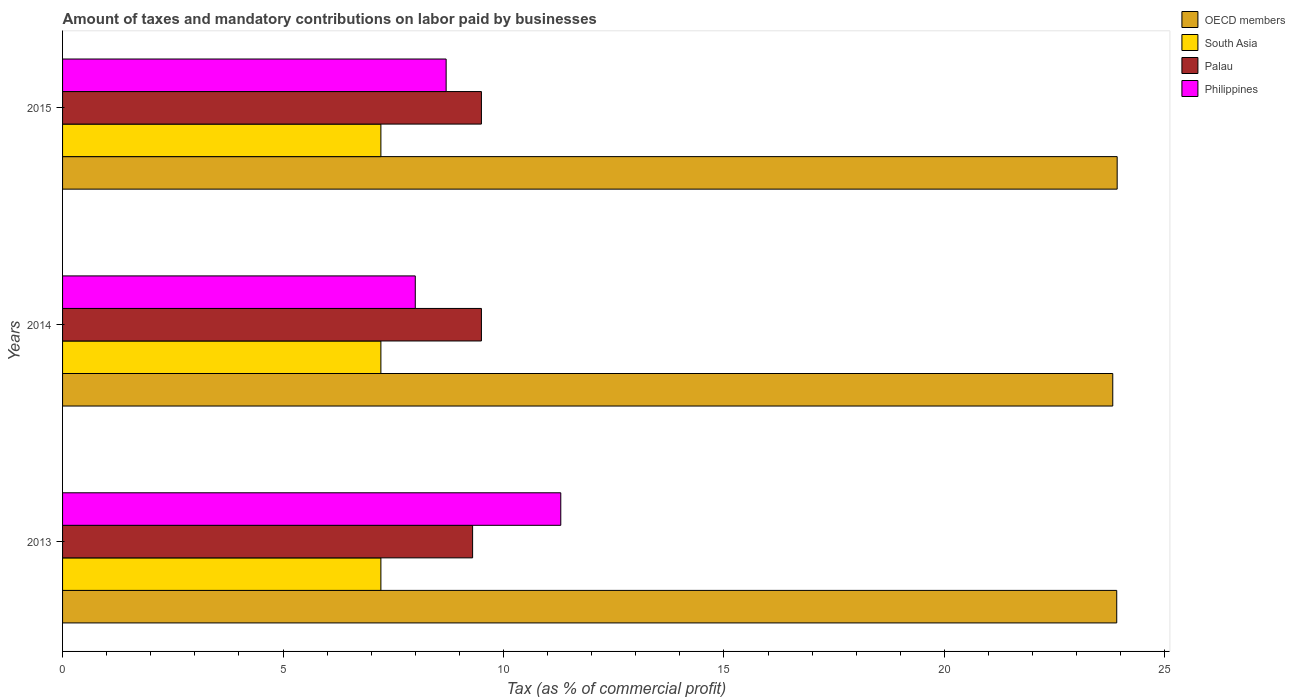How many bars are there on the 1st tick from the top?
Give a very brief answer. 4. What is the label of the 3rd group of bars from the top?
Ensure brevity in your answer.  2013. What is the percentage of taxes paid by businesses in South Asia in 2014?
Offer a very short reply. 7.22. Across all years, what is the maximum percentage of taxes paid by businesses in South Asia?
Provide a succinct answer. 7.22. Across all years, what is the minimum percentage of taxes paid by businesses in Palau?
Your answer should be compact. 9.3. In which year was the percentage of taxes paid by businesses in Palau maximum?
Make the answer very short. 2014. What is the total percentage of taxes paid by businesses in OECD members in the graph?
Keep it short and to the point. 71.65. What is the difference between the percentage of taxes paid by businesses in OECD members in 2013 and that in 2015?
Your response must be concise. -0.01. What is the difference between the percentage of taxes paid by businesses in Philippines in 2014 and the percentage of taxes paid by businesses in Palau in 2015?
Provide a short and direct response. -1.5. What is the average percentage of taxes paid by businesses in South Asia per year?
Make the answer very short. 7.22. In the year 2015, what is the difference between the percentage of taxes paid by businesses in Palau and percentage of taxes paid by businesses in OECD members?
Offer a very short reply. -14.42. What is the ratio of the percentage of taxes paid by businesses in Philippines in 2013 to that in 2014?
Your answer should be very brief. 1.41. What is the difference between the highest and the second highest percentage of taxes paid by businesses in Philippines?
Keep it short and to the point. 2.6. What is the difference between the highest and the lowest percentage of taxes paid by businesses in Philippines?
Give a very brief answer. 3.3. Is the sum of the percentage of taxes paid by businesses in Palau in 2013 and 2015 greater than the maximum percentage of taxes paid by businesses in South Asia across all years?
Provide a short and direct response. Yes. What does the 3rd bar from the top in 2013 represents?
Provide a short and direct response. South Asia. What does the 3rd bar from the bottom in 2013 represents?
Provide a short and direct response. Palau. Is it the case that in every year, the sum of the percentage of taxes paid by businesses in OECD members and percentage of taxes paid by businesses in Palau is greater than the percentage of taxes paid by businesses in Philippines?
Keep it short and to the point. Yes. Are all the bars in the graph horizontal?
Your response must be concise. Yes. Are the values on the major ticks of X-axis written in scientific E-notation?
Provide a succinct answer. No. Does the graph contain any zero values?
Your answer should be very brief. No. Does the graph contain grids?
Offer a terse response. No. How are the legend labels stacked?
Make the answer very short. Vertical. What is the title of the graph?
Provide a succinct answer. Amount of taxes and mandatory contributions on labor paid by businesses. Does "Finland" appear as one of the legend labels in the graph?
Make the answer very short. No. What is the label or title of the X-axis?
Ensure brevity in your answer.  Tax (as % of commercial profit). What is the Tax (as % of commercial profit) of OECD members in 2013?
Your answer should be very brief. 23.91. What is the Tax (as % of commercial profit) in South Asia in 2013?
Provide a succinct answer. 7.22. What is the Tax (as % of commercial profit) in Palau in 2013?
Your answer should be very brief. 9.3. What is the Tax (as % of commercial profit) of OECD members in 2014?
Give a very brief answer. 23.82. What is the Tax (as % of commercial profit) of South Asia in 2014?
Your answer should be very brief. 7.22. What is the Tax (as % of commercial profit) of Palau in 2014?
Your response must be concise. 9.5. What is the Tax (as % of commercial profit) of Philippines in 2014?
Offer a terse response. 8. What is the Tax (as % of commercial profit) of OECD members in 2015?
Your answer should be very brief. 23.92. What is the Tax (as % of commercial profit) in South Asia in 2015?
Provide a short and direct response. 7.22. What is the Tax (as % of commercial profit) of Palau in 2015?
Keep it short and to the point. 9.5. What is the Tax (as % of commercial profit) in Philippines in 2015?
Your answer should be compact. 8.7. Across all years, what is the maximum Tax (as % of commercial profit) in OECD members?
Your answer should be compact. 23.92. Across all years, what is the maximum Tax (as % of commercial profit) in South Asia?
Ensure brevity in your answer.  7.22. Across all years, what is the maximum Tax (as % of commercial profit) of Palau?
Provide a succinct answer. 9.5. Across all years, what is the minimum Tax (as % of commercial profit) in OECD members?
Ensure brevity in your answer.  23.82. Across all years, what is the minimum Tax (as % of commercial profit) in South Asia?
Make the answer very short. 7.22. Across all years, what is the minimum Tax (as % of commercial profit) in Palau?
Provide a succinct answer. 9.3. What is the total Tax (as % of commercial profit) in OECD members in the graph?
Offer a very short reply. 71.65. What is the total Tax (as % of commercial profit) of South Asia in the graph?
Your answer should be compact. 21.66. What is the total Tax (as % of commercial profit) in Palau in the graph?
Make the answer very short. 28.3. What is the difference between the Tax (as % of commercial profit) in OECD members in 2013 and that in 2014?
Ensure brevity in your answer.  0.09. What is the difference between the Tax (as % of commercial profit) of Palau in 2013 and that in 2014?
Provide a succinct answer. -0.2. What is the difference between the Tax (as % of commercial profit) of OECD members in 2013 and that in 2015?
Keep it short and to the point. -0.01. What is the difference between the Tax (as % of commercial profit) in Philippines in 2013 and that in 2015?
Keep it short and to the point. 2.6. What is the difference between the Tax (as % of commercial profit) in South Asia in 2014 and that in 2015?
Your response must be concise. 0. What is the difference between the Tax (as % of commercial profit) of Palau in 2014 and that in 2015?
Keep it short and to the point. 0. What is the difference between the Tax (as % of commercial profit) of OECD members in 2013 and the Tax (as % of commercial profit) of South Asia in 2014?
Give a very brief answer. 16.69. What is the difference between the Tax (as % of commercial profit) in OECD members in 2013 and the Tax (as % of commercial profit) in Palau in 2014?
Your response must be concise. 14.41. What is the difference between the Tax (as % of commercial profit) of OECD members in 2013 and the Tax (as % of commercial profit) of Philippines in 2014?
Your answer should be very brief. 15.91. What is the difference between the Tax (as % of commercial profit) in South Asia in 2013 and the Tax (as % of commercial profit) in Palau in 2014?
Keep it short and to the point. -2.28. What is the difference between the Tax (as % of commercial profit) of South Asia in 2013 and the Tax (as % of commercial profit) of Philippines in 2014?
Ensure brevity in your answer.  -0.78. What is the difference between the Tax (as % of commercial profit) of OECD members in 2013 and the Tax (as % of commercial profit) of South Asia in 2015?
Offer a terse response. 16.69. What is the difference between the Tax (as % of commercial profit) of OECD members in 2013 and the Tax (as % of commercial profit) of Palau in 2015?
Make the answer very short. 14.41. What is the difference between the Tax (as % of commercial profit) in OECD members in 2013 and the Tax (as % of commercial profit) in Philippines in 2015?
Your answer should be very brief. 15.21. What is the difference between the Tax (as % of commercial profit) in South Asia in 2013 and the Tax (as % of commercial profit) in Palau in 2015?
Give a very brief answer. -2.28. What is the difference between the Tax (as % of commercial profit) in South Asia in 2013 and the Tax (as % of commercial profit) in Philippines in 2015?
Your answer should be very brief. -1.48. What is the difference between the Tax (as % of commercial profit) of Palau in 2013 and the Tax (as % of commercial profit) of Philippines in 2015?
Keep it short and to the point. 0.6. What is the difference between the Tax (as % of commercial profit) in OECD members in 2014 and the Tax (as % of commercial profit) in South Asia in 2015?
Give a very brief answer. 16.6. What is the difference between the Tax (as % of commercial profit) of OECD members in 2014 and the Tax (as % of commercial profit) of Palau in 2015?
Provide a short and direct response. 14.32. What is the difference between the Tax (as % of commercial profit) in OECD members in 2014 and the Tax (as % of commercial profit) in Philippines in 2015?
Provide a succinct answer. 15.12. What is the difference between the Tax (as % of commercial profit) of South Asia in 2014 and the Tax (as % of commercial profit) of Palau in 2015?
Give a very brief answer. -2.28. What is the difference between the Tax (as % of commercial profit) in South Asia in 2014 and the Tax (as % of commercial profit) in Philippines in 2015?
Provide a succinct answer. -1.48. What is the difference between the Tax (as % of commercial profit) of Palau in 2014 and the Tax (as % of commercial profit) of Philippines in 2015?
Your response must be concise. 0.8. What is the average Tax (as % of commercial profit) in OECD members per year?
Provide a succinct answer. 23.88. What is the average Tax (as % of commercial profit) of South Asia per year?
Ensure brevity in your answer.  7.22. What is the average Tax (as % of commercial profit) in Palau per year?
Make the answer very short. 9.43. What is the average Tax (as % of commercial profit) of Philippines per year?
Ensure brevity in your answer.  9.33. In the year 2013, what is the difference between the Tax (as % of commercial profit) in OECD members and Tax (as % of commercial profit) in South Asia?
Offer a terse response. 16.69. In the year 2013, what is the difference between the Tax (as % of commercial profit) of OECD members and Tax (as % of commercial profit) of Palau?
Keep it short and to the point. 14.61. In the year 2013, what is the difference between the Tax (as % of commercial profit) of OECD members and Tax (as % of commercial profit) of Philippines?
Offer a terse response. 12.61. In the year 2013, what is the difference between the Tax (as % of commercial profit) of South Asia and Tax (as % of commercial profit) of Palau?
Your response must be concise. -2.08. In the year 2013, what is the difference between the Tax (as % of commercial profit) in South Asia and Tax (as % of commercial profit) in Philippines?
Your answer should be very brief. -4.08. In the year 2013, what is the difference between the Tax (as % of commercial profit) in Palau and Tax (as % of commercial profit) in Philippines?
Offer a terse response. -2. In the year 2014, what is the difference between the Tax (as % of commercial profit) in OECD members and Tax (as % of commercial profit) in South Asia?
Keep it short and to the point. 16.6. In the year 2014, what is the difference between the Tax (as % of commercial profit) of OECD members and Tax (as % of commercial profit) of Palau?
Ensure brevity in your answer.  14.32. In the year 2014, what is the difference between the Tax (as % of commercial profit) of OECD members and Tax (as % of commercial profit) of Philippines?
Your answer should be very brief. 15.82. In the year 2014, what is the difference between the Tax (as % of commercial profit) in South Asia and Tax (as % of commercial profit) in Palau?
Provide a succinct answer. -2.28. In the year 2014, what is the difference between the Tax (as % of commercial profit) of South Asia and Tax (as % of commercial profit) of Philippines?
Your answer should be compact. -0.78. In the year 2014, what is the difference between the Tax (as % of commercial profit) of Palau and Tax (as % of commercial profit) of Philippines?
Make the answer very short. 1.5. In the year 2015, what is the difference between the Tax (as % of commercial profit) in OECD members and Tax (as % of commercial profit) in South Asia?
Make the answer very short. 16.7. In the year 2015, what is the difference between the Tax (as % of commercial profit) in OECD members and Tax (as % of commercial profit) in Palau?
Your response must be concise. 14.42. In the year 2015, what is the difference between the Tax (as % of commercial profit) of OECD members and Tax (as % of commercial profit) of Philippines?
Make the answer very short. 15.22. In the year 2015, what is the difference between the Tax (as % of commercial profit) of South Asia and Tax (as % of commercial profit) of Palau?
Make the answer very short. -2.28. In the year 2015, what is the difference between the Tax (as % of commercial profit) of South Asia and Tax (as % of commercial profit) of Philippines?
Offer a very short reply. -1.48. In the year 2015, what is the difference between the Tax (as % of commercial profit) of Palau and Tax (as % of commercial profit) of Philippines?
Your response must be concise. 0.8. What is the ratio of the Tax (as % of commercial profit) in South Asia in 2013 to that in 2014?
Offer a terse response. 1. What is the ratio of the Tax (as % of commercial profit) in Palau in 2013 to that in 2014?
Your response must be concise. 0.98. What is the ratio of the Tax (as % of commercial profit) in Philippines in 2013 to that in 2014?
Keep it short and to the point. 1.41. What is the ratio of the Tax (as % of commercial profit) in South Asia in 2013 to that in 2015?
Your answer should be compact. 1. What is the ratio of the Tax (as % of commercial profit) of Palau in 2013 to that in 2015?
Offer a very short reply. 0.98. What is the ratio of the Tax (as % of commercial profit) in Philippines in 2013 to that in 2015?
Offer a very short reply. 1.3. What is the ratio of the Tax (as % of commercial profit) of Palau in 2014 to that in 2015?
Make the answer very short. 1. What is the ratio of the Tax (as % of commercial profit) in Philippines in 2014 to that in 2015?
Make the answer very short. 0.92. What is the difference between the highest and the second highest Tax (as % of commercial profit) of OECD members?
Your answer should be very brief. 0.01. What is the difference between the highest and the second highest Tax (as % of commercial profit) in Philippines?
Ensure brevity in your answer.  2.6. What is the difference between the highest and the lowest Tax (as % of commercial profit) in OECD members?
Provide a succinct answer. 0.1. What is the difference between the highest and the lowest Tax (as % of commercial profit) in South Asia?
Provide a short and direct response. 0. 